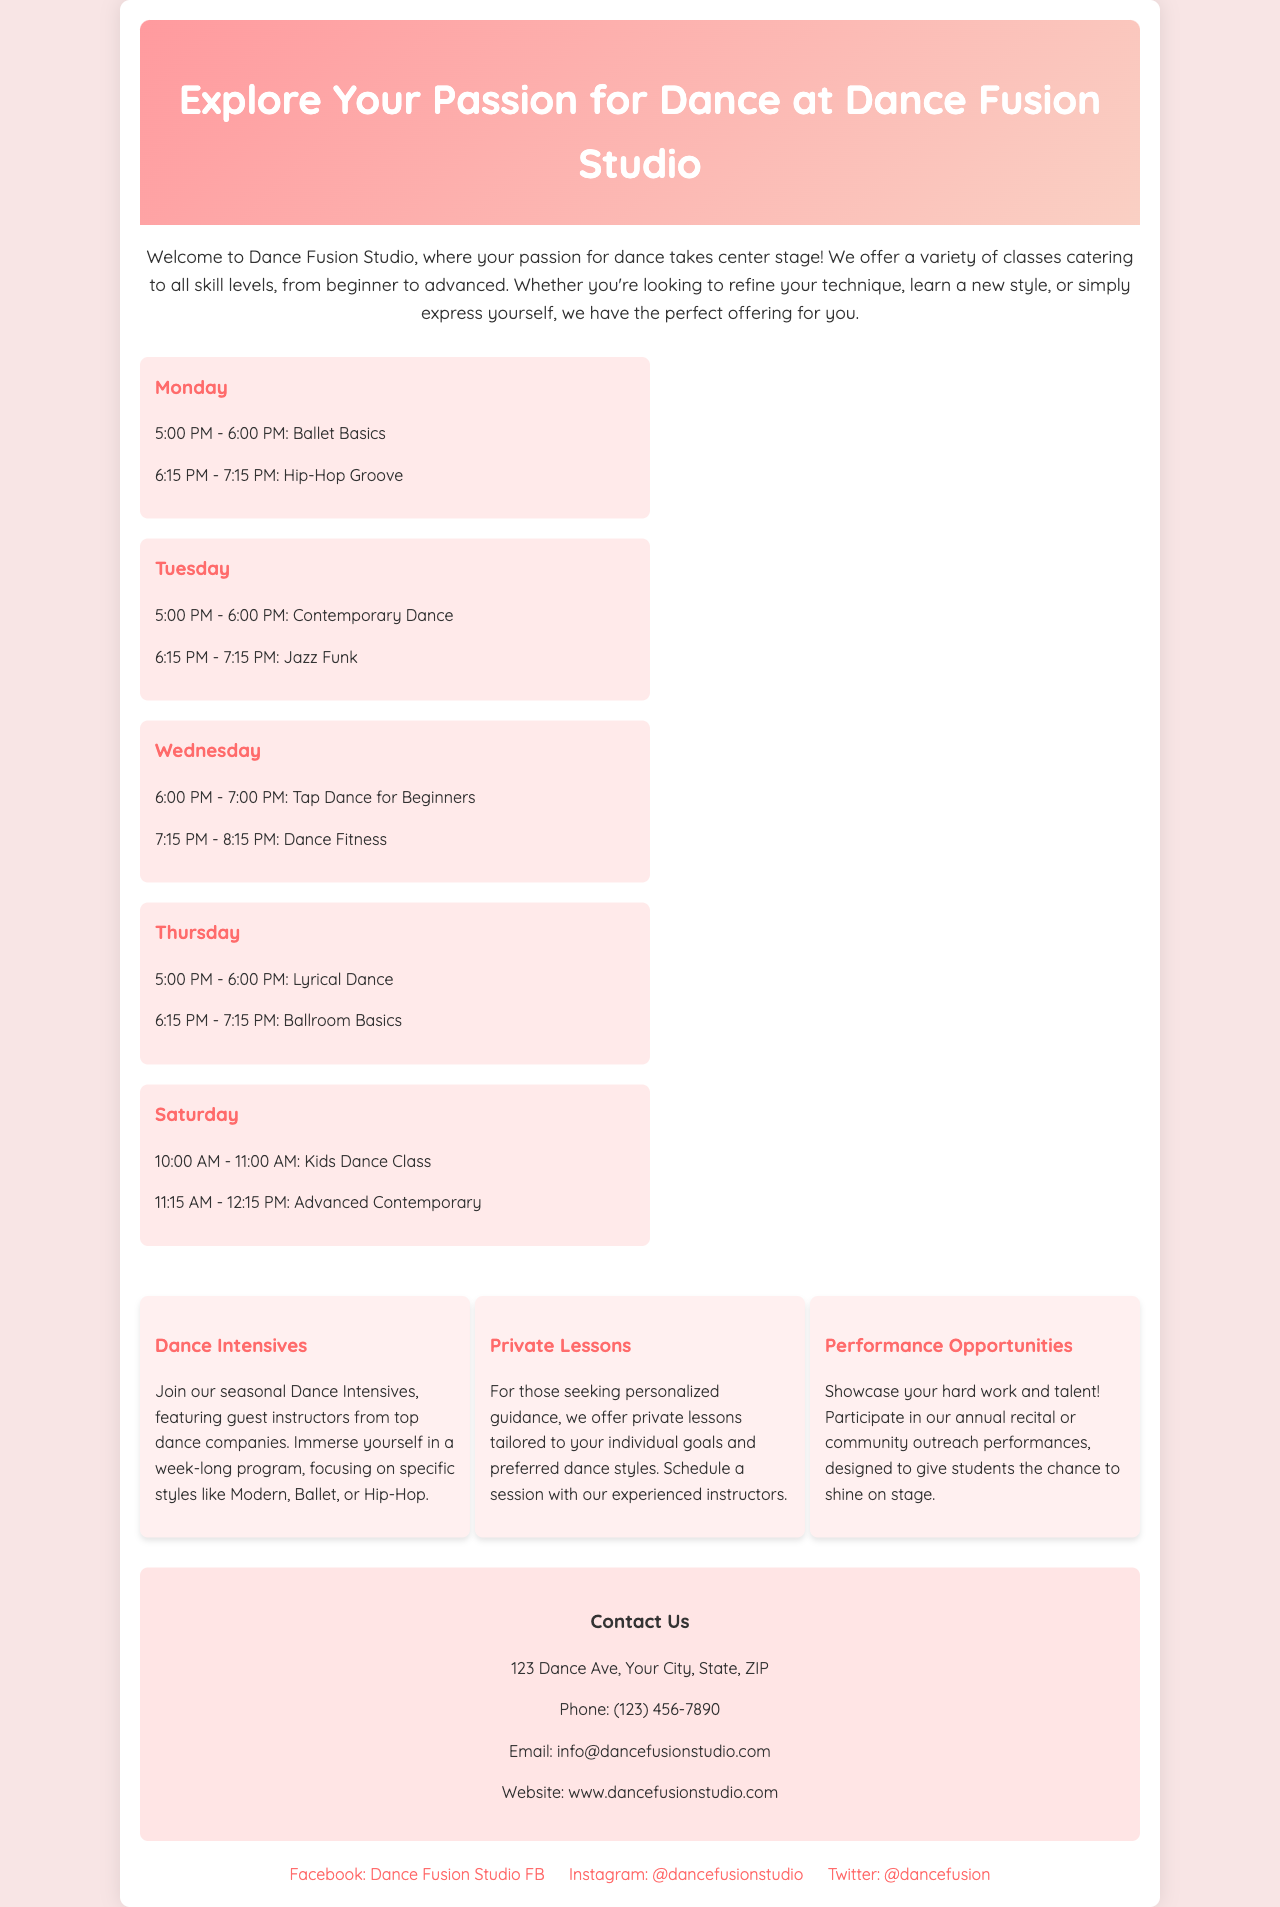What time does the Ballet Basics class start on Monday? The Ballet Basics class on Monday starts at 5:00 PM.
Answer: 5:00 PM What are the two classes offered on Tuesday? The classes offered on Tuesday are Contemporary Dance and Jazz Funk.
Answer: Contemporary Dance, Jazz Funk How many offerings are listed in the brochure? The brochure lists three offerings: Dance Intensives, Private Lessons, and Performance Opportunities.
Answer: Three What is the address of Dance Fusion Studio? The address provided for Dance Fusion Studio is 123 Dance Ave, Your City, State, ZIP.
Answer: 123 Dance Ave, Your City, State, ZIP How long is each dance class session? Each dance class session lasts for one hour.
Answer: One hour What is the focus of the Dance Intensives? The Dance Intensives focus on specific styles like Modern, Ballet, or Hip-Hop.
Answer: Specific styles like Modern, Ballet, or Hip-Hop Which day has a Kids Dance Class scheduled? The Kids Dance Class is scheduled for Saturday.
Answer: Saturday What type of opportunities does the studio provide for showcasing talent? The studio provides opportunities for participating in annual recitals or community outreach performances.
Answer: Annual recitals or community outreach performances 